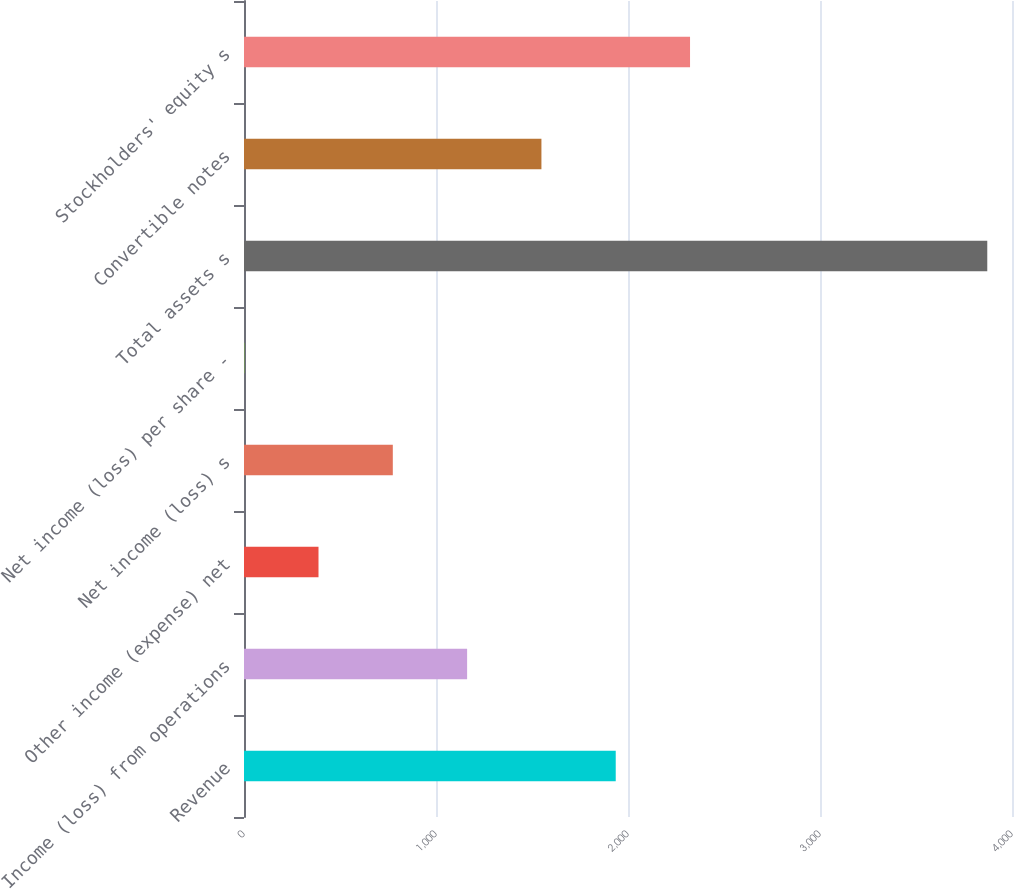Convert chart to OTSL. <chart><loc_0><loc_0><loc_500><loc_500><bar_chart><fcel>Revenue<fcel>Income (loss) from operations<fcel>Other income (expense) net<fcel>Net income (loss) s<fcel>Net income (loss) per share -<fcel>Total assets s<fcel>Convertible notes<fcel>Stockholders' equity s<nl><fcel>1936.11<fcel>1162.07<fcel>388.03<fcel>775.05<fcel>1.01<fcel>3871.2<fcel>1549.09<fcel>2323.13<nl></chart> 